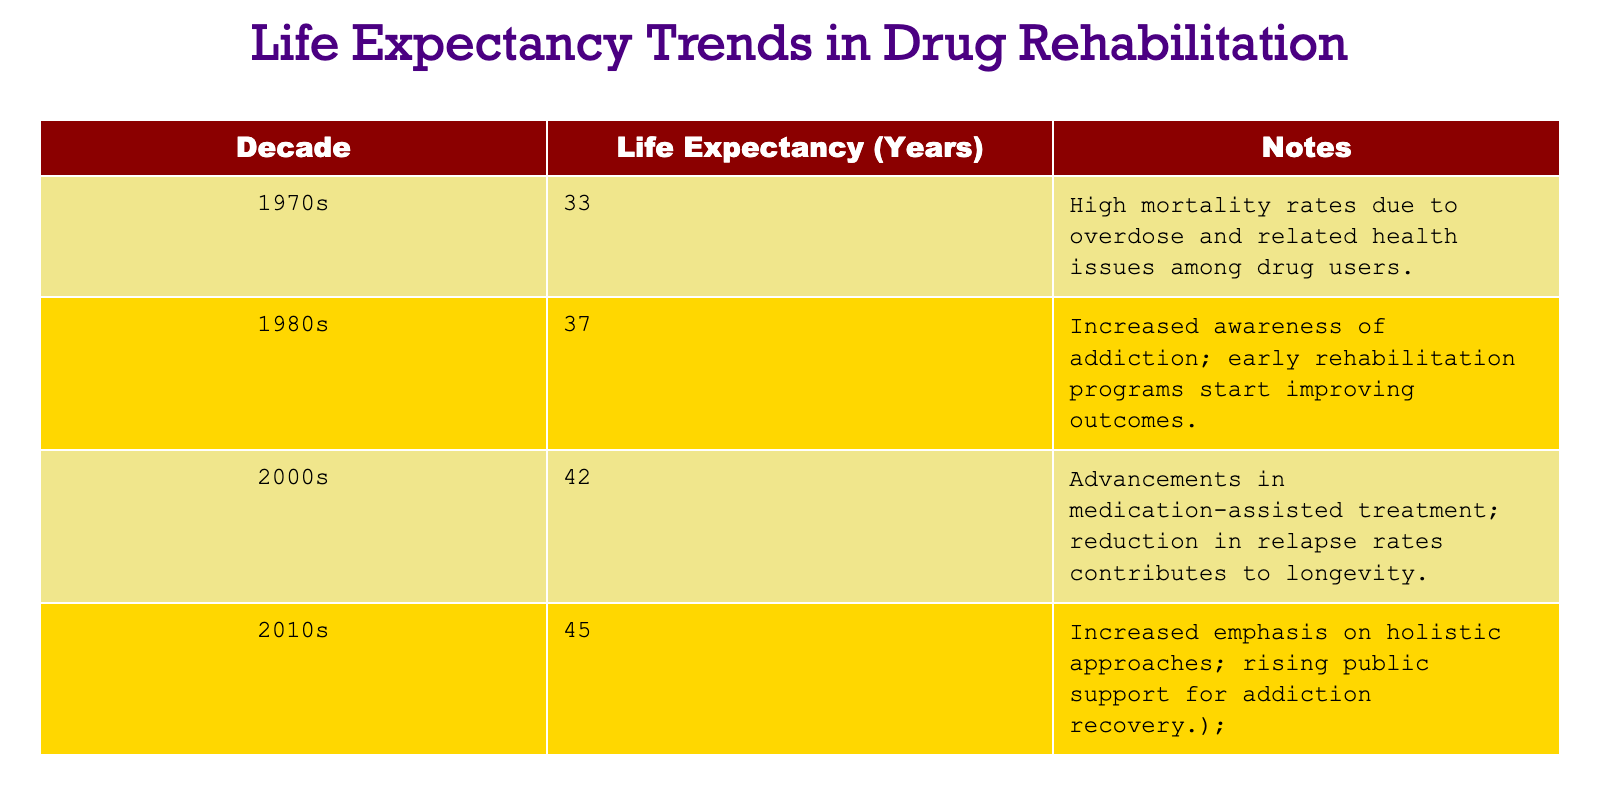What was the life expectancy for drug rehabilitation patients in the 1970s? The table shows that the life expectancy in the 1970s was 33 years.
Answer: 33 What decade saw the greatest increase in life expectancy compared to the previous decade? By comparing the life expectancy figures, the greatest increase occurred from the 1990s to the 2000s, rising from 37 years to 42 years, an increase of 5 years.
Answer: From the 1990s to the 2000s What is the average life expectancy from the 1980s to the 2010s? The life expectancies from the 1980s to the 2010s are 37, 42, and 45 years. Summing them gives 37 + 42 + 45 = 124, and dividing by 3 provides the average: 124 / 3 = 41.33.
Answer: 41.33 Did the life expectancy consistently increase over the decades presented? Yes, looking at the figures from the 1970s (33 years) to the 2010s (45 years), we see consistent growth without any declines.
Answer: Yes How much did life expectancy increase from the 2000s to the 2010s? The life expectancy was 42 years in the 2000s and 45 years in the 2010s. The increase is calculated as 45 - 42 = 3 years.
Answer: 3 years Which decade had the highest life expectancy, and what was it? Referencing the table, the highest life expectancy was in the 2010s, which was 45 years.
Answer: 2010s, 45 years What was the life expectancy in the 1980s and how does it compare to the life expectancy in the 1970s? The life expectancy in the 1980s was 37 years, compared to 33 years in the 1970s. This shows an increase of 4 years (37 - 33 = 4).
Answer: 37 years; increased by 4 years Was there an increase in public support for addiction recovery noted in the notes of the table? Yes, the notes for the 2010s mention a "rising public support for addiction recovery."
Answer: Yes What decade appears to have made significant advancements in treatment methods? The 2000s are noted for "advancements in medication-assisted treatment" which significantly impacted life expectancy.
Answer: 2000s 